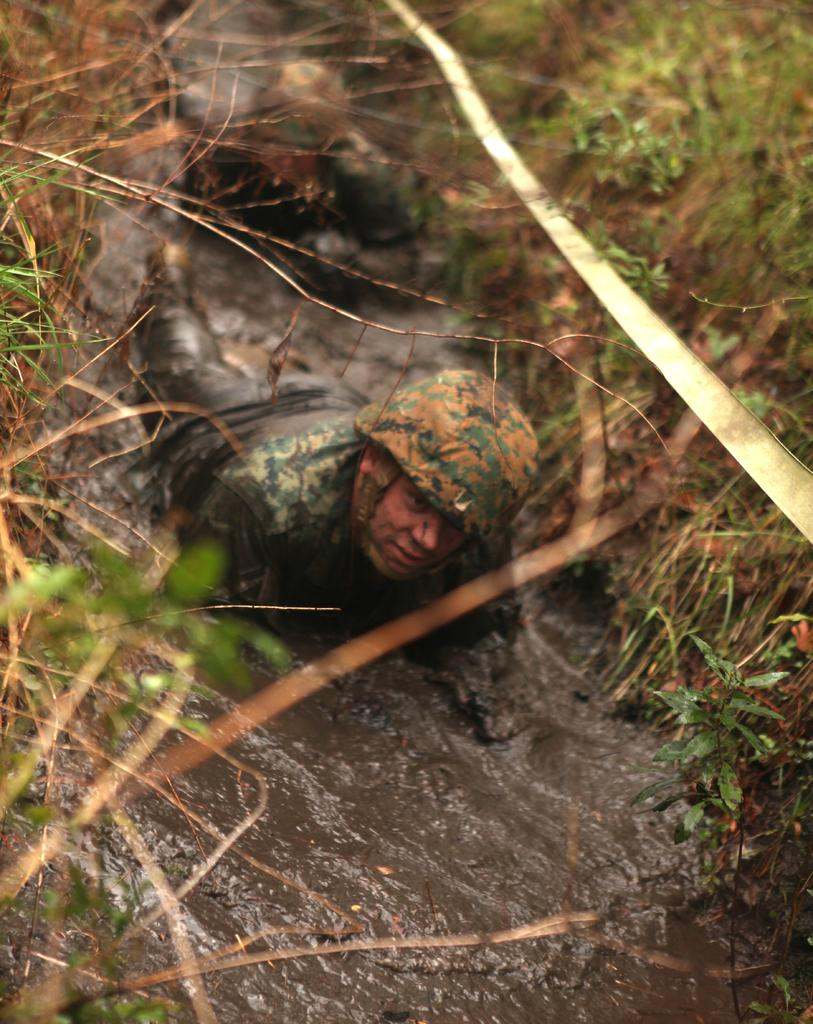Who or what can be seen in the image? There are people in the image. What is the surface that the people are standing on or interacting with? The ground is visible in the image. Are there any natural elements present in the image? Yes, there are plants in the image. Can you tell me how the stream flows in the image? There is no stream present in the image; it only features people, the ground, and plants. 